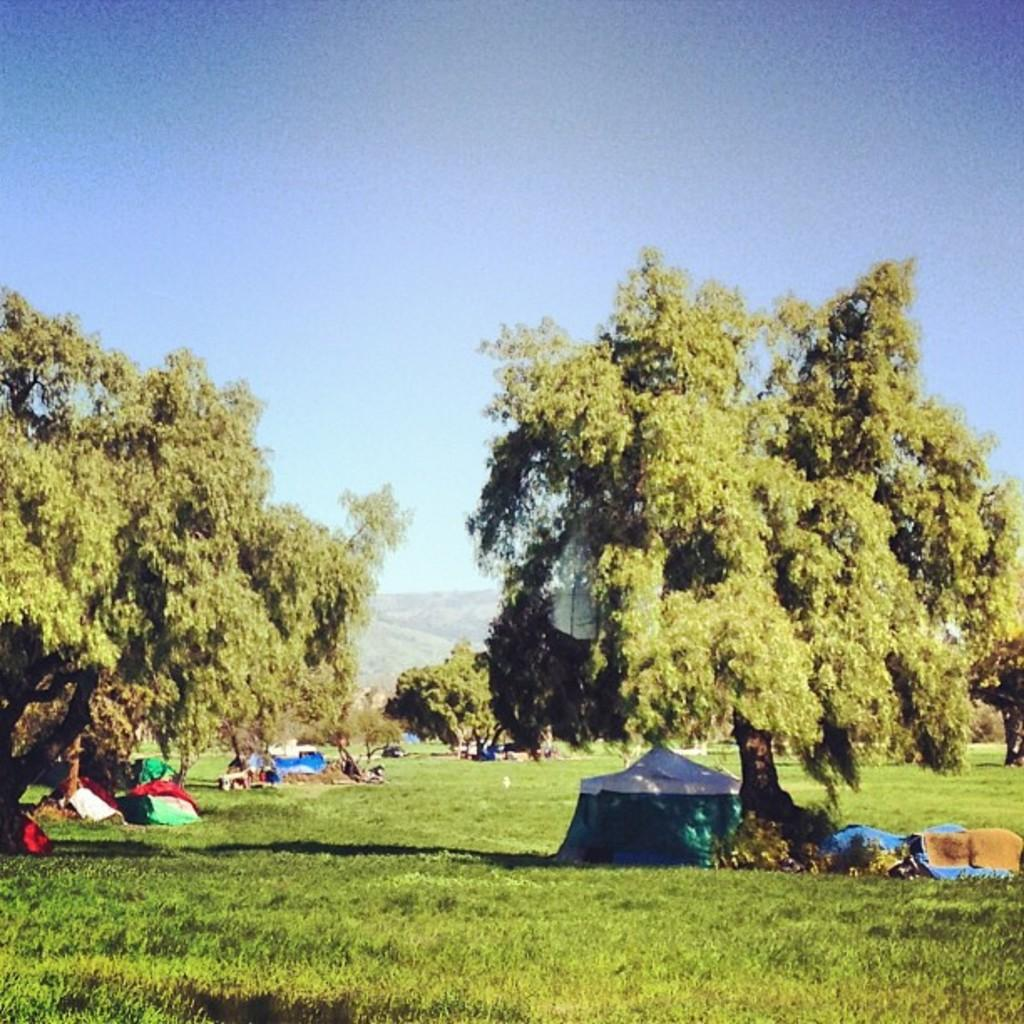What type of vegetation can be seen in the image? There are trees in the image. What type of temporary shelter is visible in the image? There are tents in the image. What geographical feature can be seen in the background of the image? There is a hill visible in the background of the image. Can you find the receipt for the purchase of the trees in the image? There is no receipt present in the image, as it is a photograph of trees and tents, not a transaction record. What type of pickle is being used to hold the tents in place in the image? There are no pickles present in the image; the tents are likely secured with stakes or other camping equipment. 